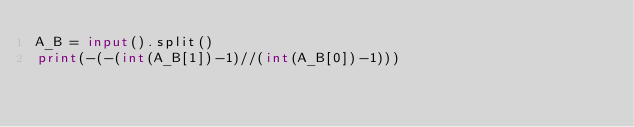<code> <loc_0><loc_0><loc_500><loc_500><_Python_>A_B = input().split()
print(-(-(int(A_B[1])-1)//(int(A_B[0])-1)))</code> 